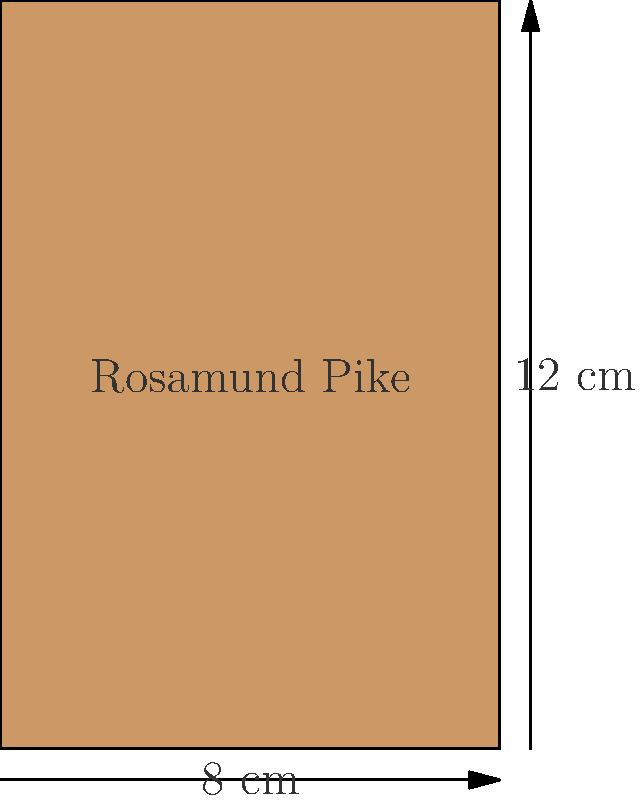A local cinema is promoting Rosamund Pike's latest film with a rectangular movie poster. The poster measures 8 cm in width and 12 cm in height. What is the area of the movie poster in square centimeters? To find the area of a rectangular movie poster, we need to multiply its width by its height. Let's break it down step-by-step:

1. Identify the dimensions:
   - Width = 8 cm
   - Height = 12 cm

2. Use the formula for the area of a rectangle:
   $$ \text{Area} = \text{width} \times \text{height} $$

3. Substitute the values into the formula:
   $$ \text{Area} = 8 \text{ cm} \times 12 \text{ cm} $$

4. Perform the multiplication:
   $$ \text{Area} = 96 \text{ cm}^2 $$

Therefore, the area of the Rosamund Pike movie poster is 96 square centimeters.
Answer: $96 \text{ cm}^2$ 